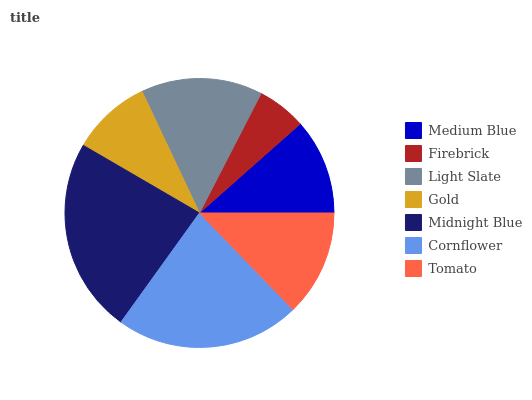Is Firebrick the minimum?
Answer yes or no. Yes. Is Midnight Blue the maximum?
Answer yes or no. Yes. Is Light Slate the minimum?
Answer yes or no. No. Is Light Slate the maximum?
Answer yes or no. No. Is Light Slate greater than Firebrick?
Answer yes or no. Yes. Is Firebrick less than Light Slate?
Answer yes or no. Yes. Is Firebrick greater than Light Slate?
Answer yes or no. No. Is Light Slate less than Firebrick?
Answer yes or no. No. Is Tomato the high median?
Answer yes or no. Yes. Is Tomato the low median?
Answer yes or no. Yes. Is Midnight Blue the high median?
Answer yes or no. No. Is Light Slate the low median?
Answer yes or no. No. 